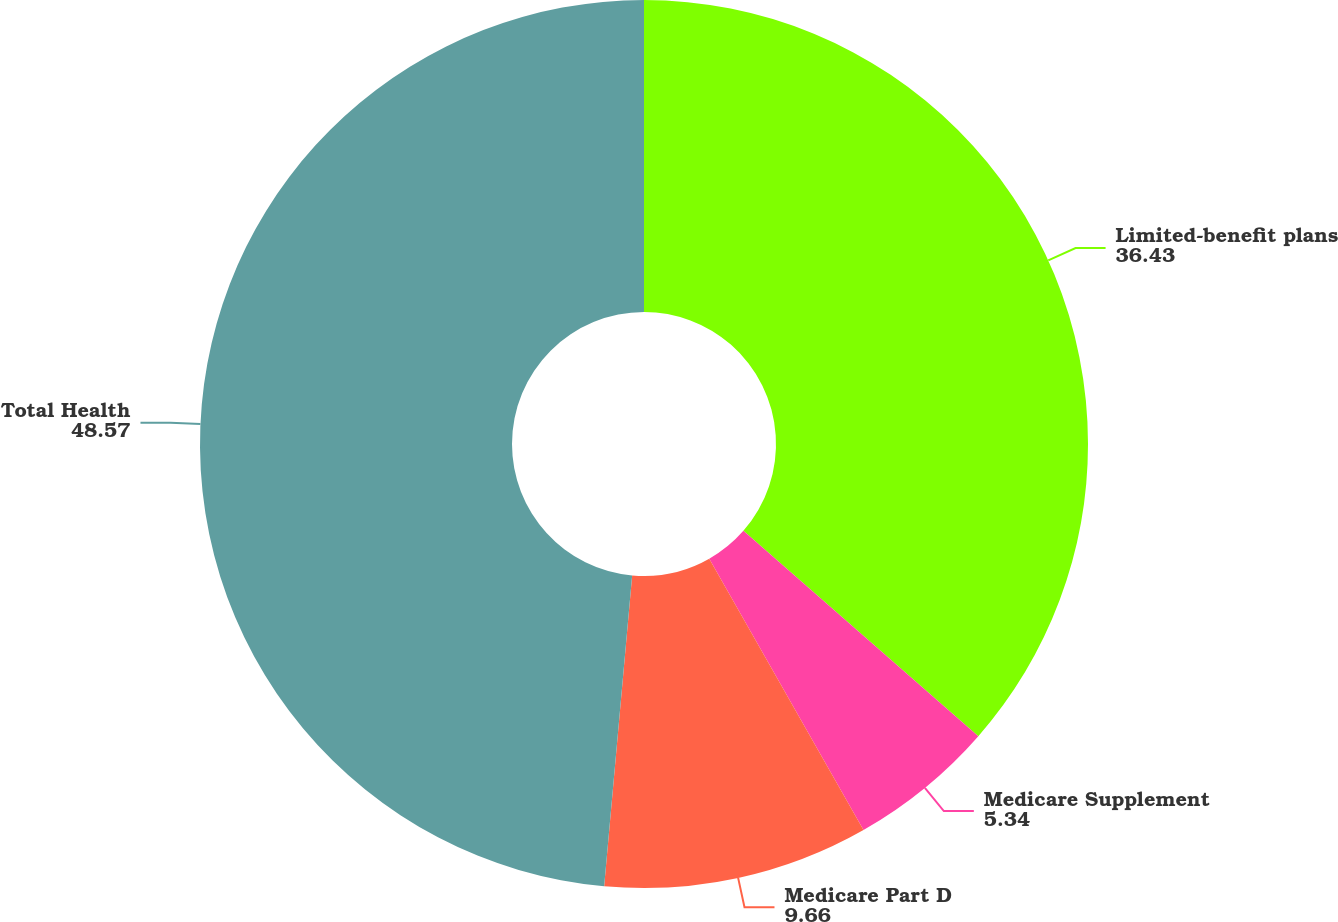Convert chart. <chart><loc_0><loc_0><loc_500><loc_500><pie_chart><fcel>Limited-benefit plans<fcel>Medicare Supplement<fcel>Medicare Part D<fcel>Total Health<nl><fcel>36.43%<fcel>5.34%<fcel>9.66%<fcel>48.57%<nl></chart> 